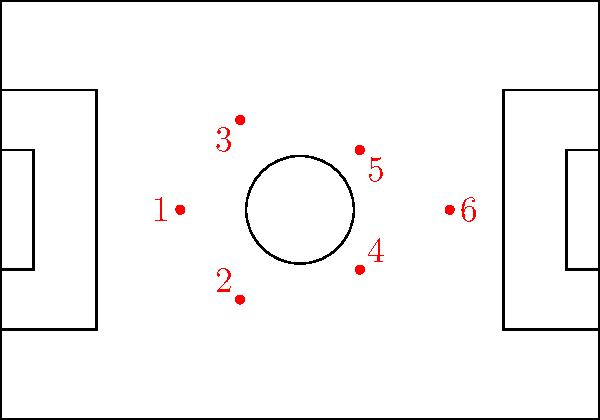Given the soccer field diagram with six players (numbered 1-6) in a 3-3 formation, which player should be moved to create a more defensive 4-2 formation that maximizes field coverage and maintains strong counter-attack potential? To optimize the formation for a more defensive 4-2 setup while maintaining counter-attack potential, we need to consider the following steps:

1. Analyze the current 3-3 formation:
   - Players 1, 2, and 3 form the back line
   - Players 4, 5, and 6 form the front line

2. Identify the objectives of a 4-2 formation:
   - Strengthen the defense by adding an extra defender
   - Maintain two midfielders for balance and counter-attack potential

3. Evaluate each player's position:
   - Player 1 is centrally positioned and should remain as the central defender
   - Players 2 and 3 are already in good positions as wide defenders
   - Players 4 and 5 are in good positions to act as the two midfielders
   - Player 6 is the furthest forward and most suited to move back

4. Determine the optimal move:
   - Moving Player 6 back to join the defensive line creates the desired 4-2 formation
   - This move strengthens the defense while keeping Players 4 and 5 in position for counter-attacks

5. Advantages of this move:
   - Creates a solid back four with Player 6 joining Players 1, 2, and 3
   - Maintains the central positioning of Players 4 and 5 for midfield control and quick transitions

By moving Player 6 back to create a four-player defensive line, we optimize the formation for better defense while maintaining the ability to counter-attack through the two midfielders.
Answer: Player 6 